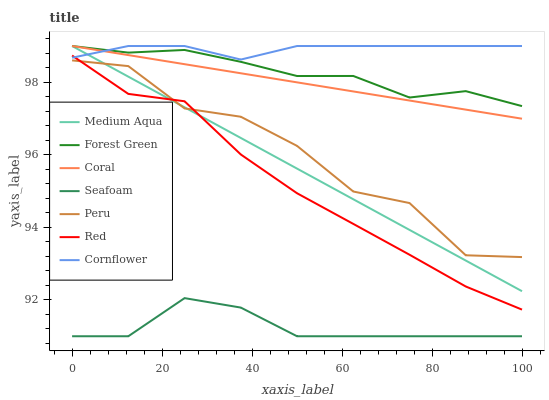Does Seafoam have the minimum area under the curve?
Answer yes or no. Yes. Does Cornflower have the maximum area under the curve?
Answer yes or no. Yes. Does Coral have the minimum area under the curve?
Answer yes or no. No. Does Coral have the maximum area under the curve?
Answer yes or no. No. Is Medium Aqua the smoothest?
Answer yes or no. Yes. Is Peru the roughest?
Answer yes or no. Yes. Is Coral the smoothest?
Answer yes or no. No. Is Coral the roughest?
Answer yes or no. No. Does Seafoam have the lowest value?
Answer yes or no. Yes. Does Coral have the lowest value?
Answer yes or no. No. Does Medium Aqua have the highest value?
Answer yes or no. Yes. Does Seafoam have the highest value?
Answer yes or no. No. Is Seafoam less than Forest Green?
Answer yes or no. Yes. Is Coral greater than Red?
Answer yes or no. Yes. Does Forest Green intersect Coral?
Answer yes or no. Yes. Is Forest Green less than Coral?
Answer yes or no. No. Is Forest Green greater than Coral?
Answer yes or no. No. Does Seafoam intersect Forest Green?
Answer yes or no. No. 